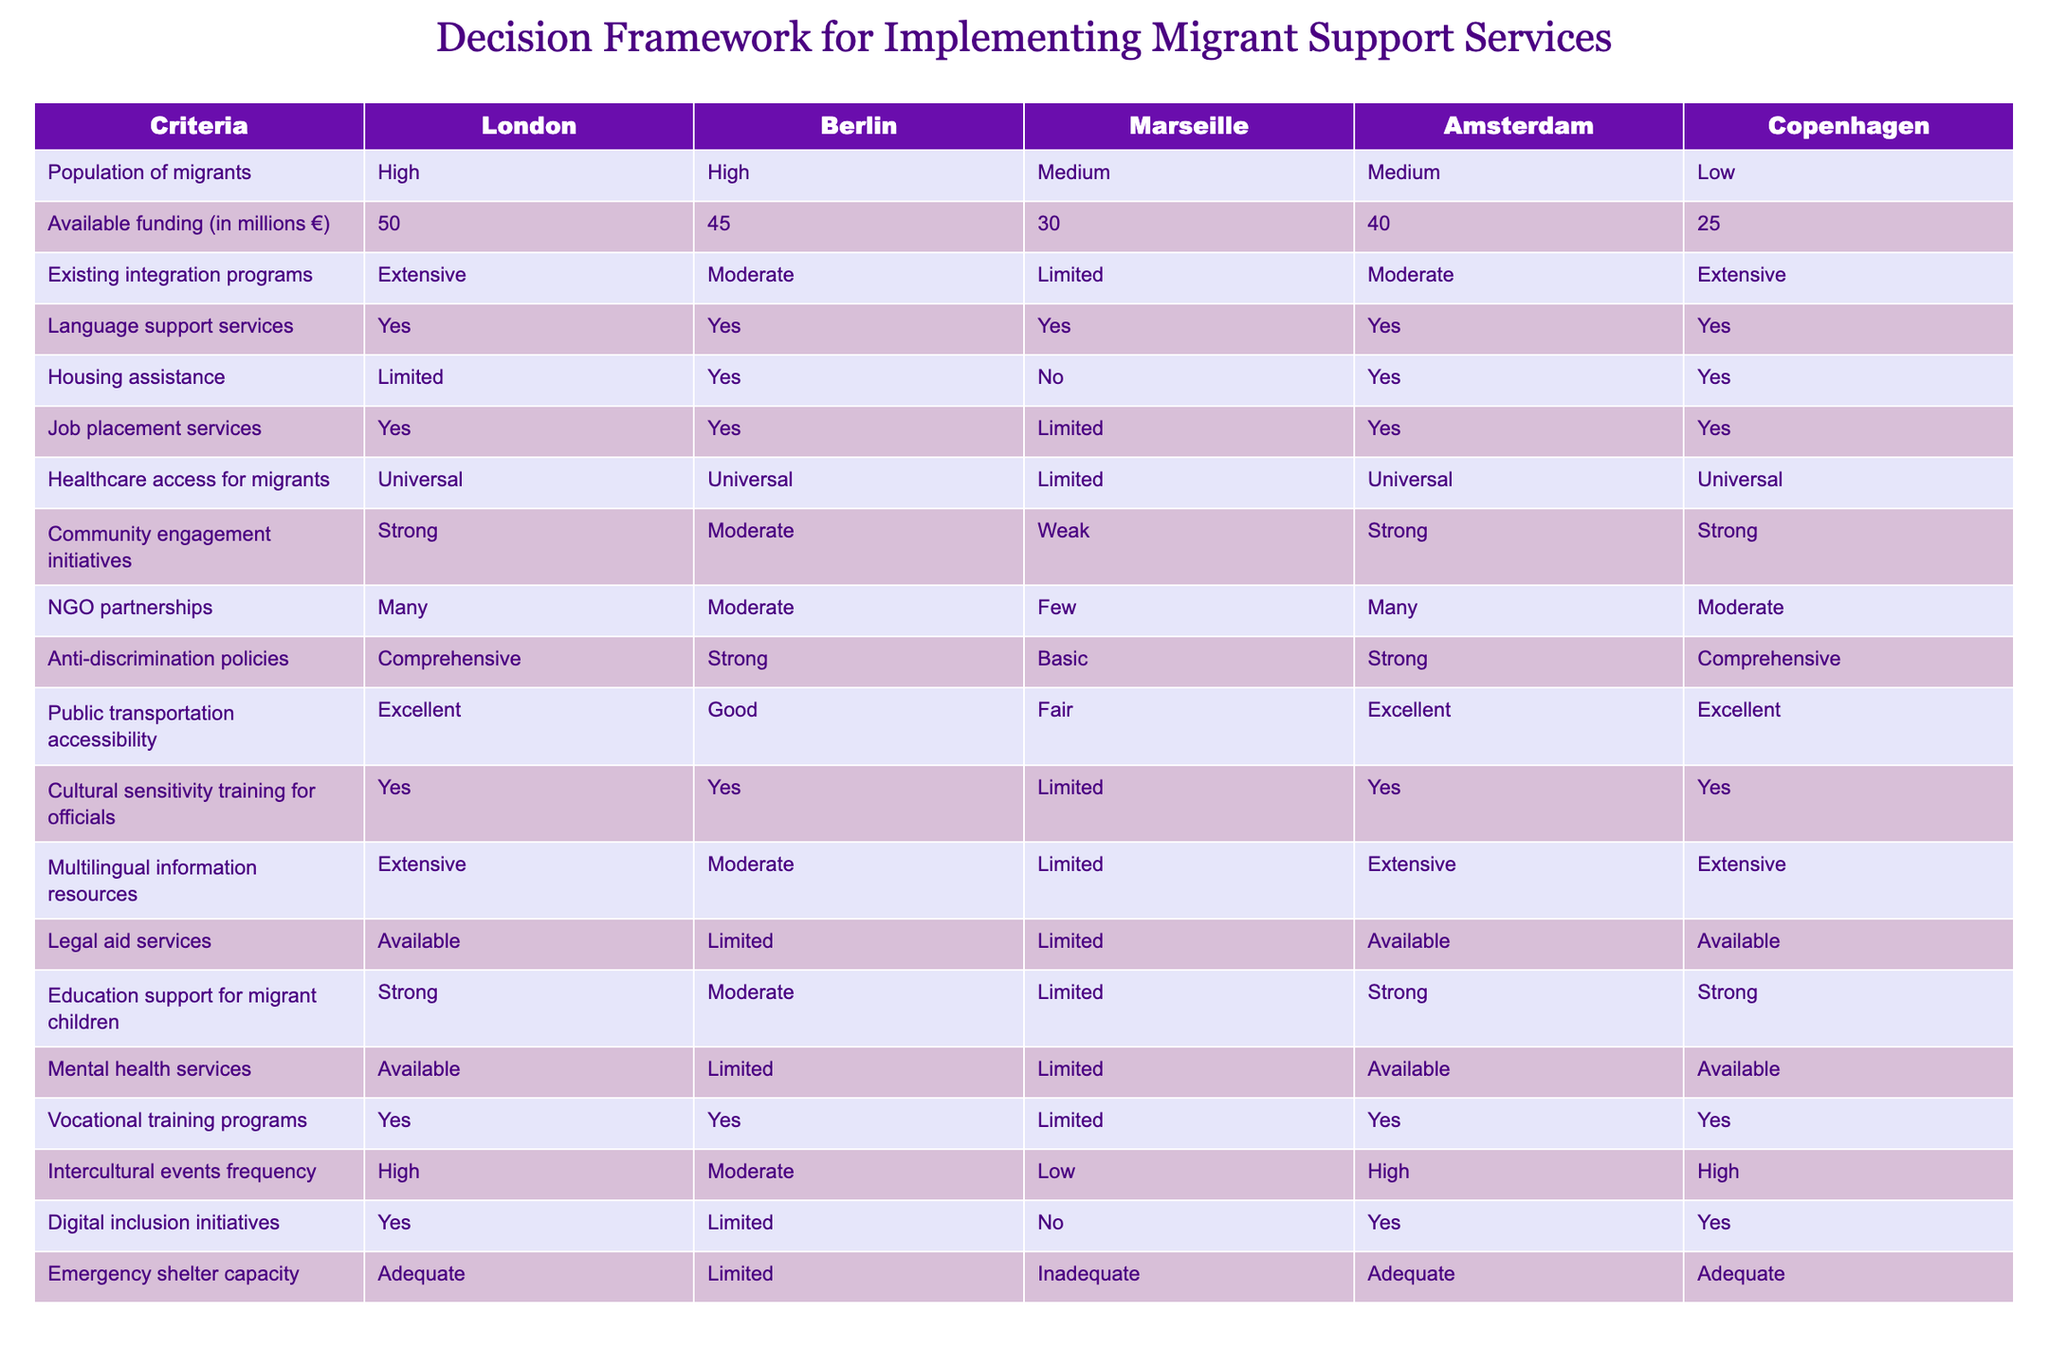What is the population of migrants in Marseille? In the table, the population of migrants in the Marseille row is labeled as "Medium." There are no calculations needed, just a direct reading of the table.
Answer: Medium Which city has the highest available funding for migrant support services? The available funding values for each city are compared: London has 50 million €, Berlin has 45 million €, Marseille has 30 million €, Amsterdam has 40 million €, and Copenhagen has 25 million €. London has the highest amount.
Answer: London Are language support services available in Copenhagen? Looking at the Copenhagen row in the language support services column, it states "Yes." Therefore, language support services are available there.
Answer: Yes How many cities have limited housing assistance? By reviewing the housing assistance column, the cities with limited assistance are Marseille (No), Berlin (Yes), and Copenhagen (Yes). So, there are three cities (Berlin, Marseille, and Copenhagen) with limited housing assistance.
Answer: Three What is the total funding available for urban areas with high populations of migrants? The cities with high migrant populations are London and Berlin. Their funding amounts are 50 million € (London) and 45 million € (Berlin). The total funding is 50 + 45 = 95 million €.
Answer: 95 million € Which city has the weakest community engagement initiatives? The community engagement column reveals the levels for each city: London is "Strong," Berlin is "Moderate," Marseille is "Weak," Amsterdam is "Strong," and Copenhagen is "Strong." Thus, Marseille has the weakest initiatives.
Answer: Marseille Is there legal aid services available in Marseille? Referring to the legal aid services column for Marseille, it is marked as "Limited." Therefore, legal aid services are not fully available.
Answer: No How many cities offer extensive vocational training programs? The vocational training column shows that London, Berlin, Amsterdam, and Copenhagen all have vocational training programs listed as "Yes," while Marseille has "Limited." So, that totals four cities offering extensive vocational training.
Answer: Four What is the average level of public transportation accessibility across the cities? Evaluating the accessibility levels: London (Excellent), Berlin (Good), Marseille (Fair), Amsterdam (Excellent), and Copenhagen (Excellent). Assigning values (Excellent=4, Good=3, Fair=2), the average calculated is (4 + 3 + 2 + 4 + 4) / 5 = 17 / 5 = 3.4 which is approximately "Good."
Answer: Good 